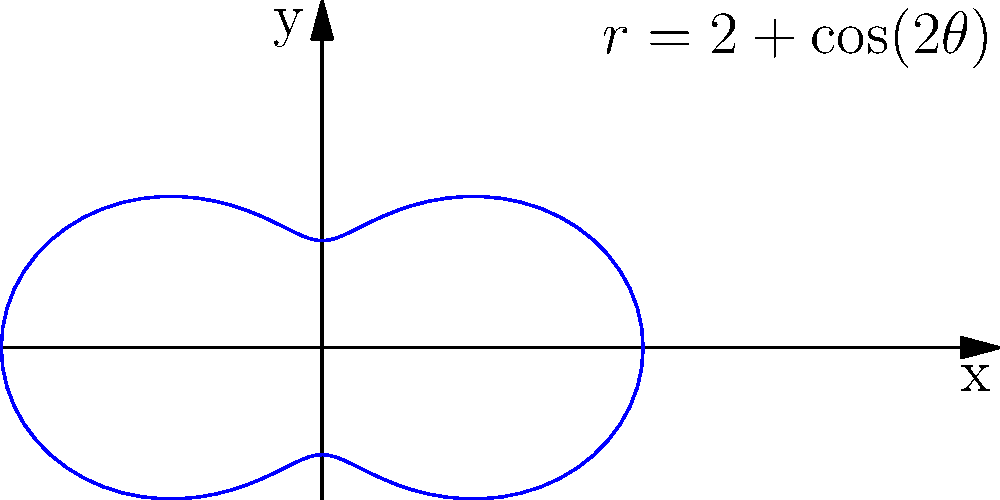As a wireless technology enthusiast, you're working on a DIY antenna project. The radiation pattern of your antenna is described by the polar equation $r = 2 + \cos(2\theta)$. Calculate the antenna gain in dB for the direction $\theta = \frac{\pi}{4}$ relative to the maximum radiation direction. Let's approach this step-by-step:

1) First, we need to find the maximum value of $r$. This occurs when $\cos(2\theta) = 1$, which happens when $2\theta = 0, 2\pi, 4\pi, ...$
   So, $r_{max} = 2 + 1 = 3$

2) Now, let's calculate $r$ for $\theta = \frac{\pi}{4}$:
   $r(\frac{\pi}{4}) = 2 + \cos(2\cdot\frac{\pi}{4}) = 2 + \cos(\frac{\pi}{2}) = 2 + 0 = 2$

3) The antenna gain is the ratio of the power density in a given direction to the power density that would be radiated by an isotropic radiator. In polar coordinates, this is proportional to the square of the $r$ values.

4) The gain relative to the maximum direction is:
   $G = (\frac{r(\frac{\pi}{4})}{r_{max}})^2 = (\frac{2}{3})^2 = \frac{4}{9}$

5) To convert this to dB, we use the formula:
   $G_{dB} = 10 \log_{10}(G) = 10 \log_{10}(\frac{4}{9}) \approx -3.52$ dB

Therefore, the antenna gain in the direction $\theta = \frac{\pi}{4}$ relative to the maximum radiation direction is approximately -3.52 dB.
Answer: $-3.52$ dB 